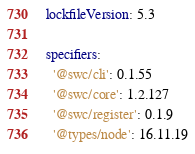<code> <loc_0><loc_0><loc_500><loc_500><_YAML_>lockfileVersion: 5.3

specifiers:
  '@swc/cli': 0.1.55
  '@swc/core': 1.2.127
  '@swc/register': 0.1.9
  '@types/node': 16.11.19</code> 